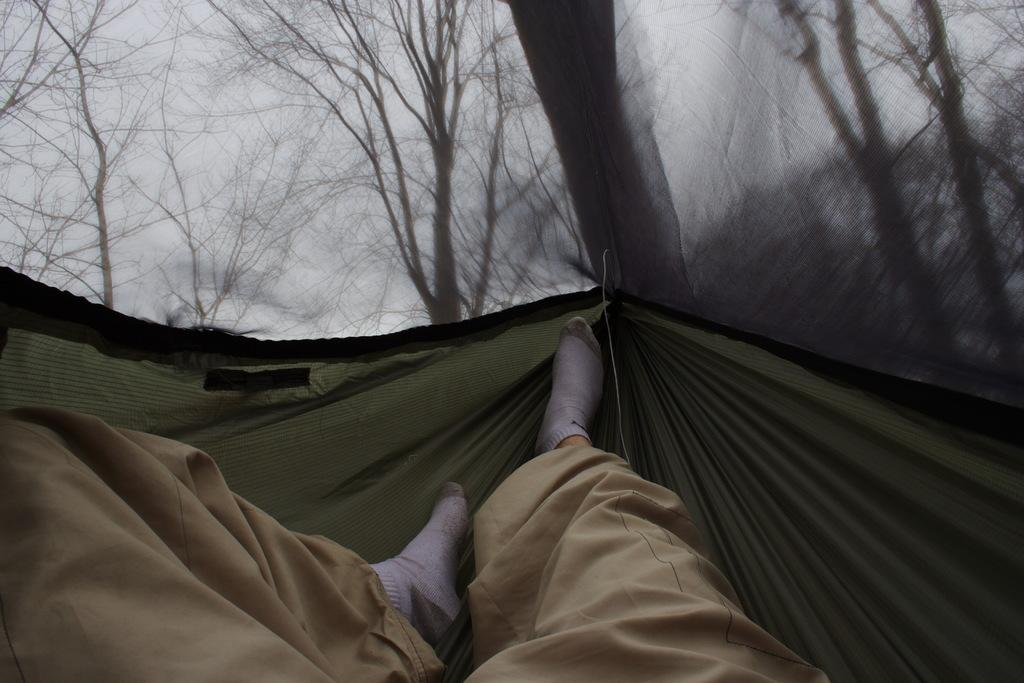Who or what is the main subject in the image? There is a person in the image. What part of the person's body is visible on a cloth? The person's legs are visible on a cloth. What can be seen in the distance behind the person? There are trees in the background of the image. How would you describe the appearance of the background? The background is blurred. What type of tank can be seen in the image? There is no tank present in the image. Can you hear thunder in the image? The image is silent, and there is no indication of thunder or any sound. 